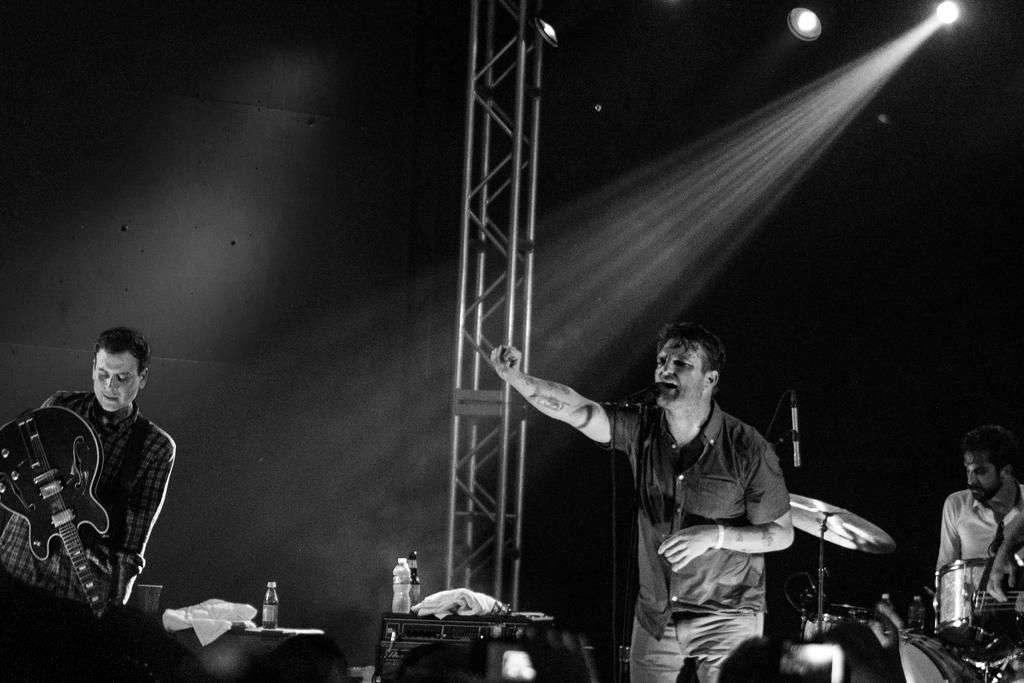Describe this image in one or two sentences. In this image there are three persons. To the right there is man whose is playing drums. And in the middle the man who is singing in the mic. To left the man is playing guitar. And in the middle there is a stand to which a light is fixed. To the top right there is a light from which the rays are falling on the stage. 